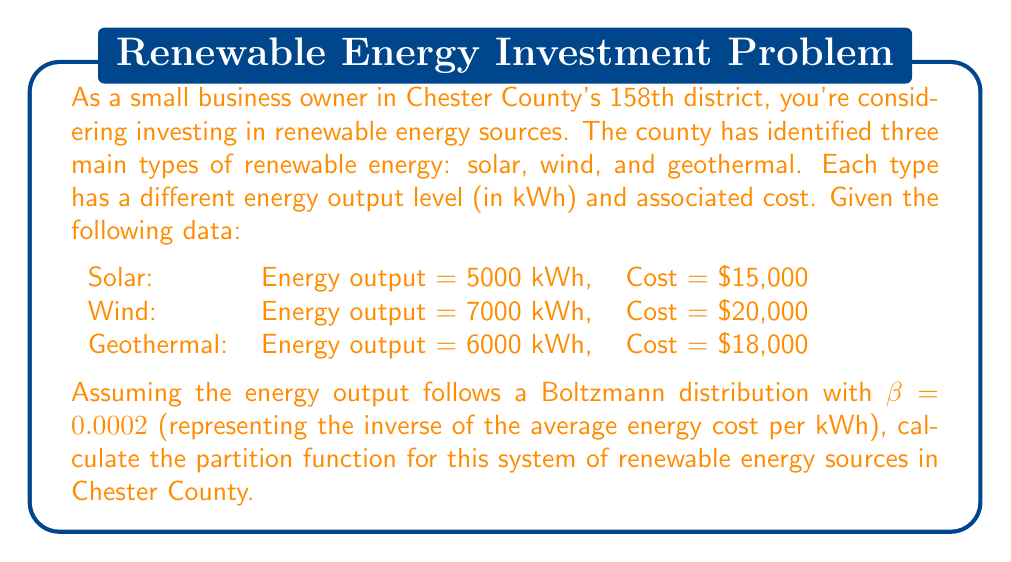Give your solution to this math problem. To solve this problem, we'll follow these steps:

1) Recall that the partition function Z for a system with discrete energy levels is given by:

   $$Z = \sum_i e^{-\beta E_i}$$

   where $E_i$ are the energy levels and $\beta$ is the inverse temperature parameter.

2) In our case, $\beta = 0.0002$ and we have three energy levels corresponding to the three types of renewable energy sources.

3) Let's calculate the exponent for each energy source:

   Solar: $e^{-0.0002 \cdot 5000} = e^{-1} \approx 0.3679$
   Wind: $e^{-0.0002 \cdot 7000} = e^{-1.4} \approx 0.2466$
   Geothermal: $e^{-0.0002 \cdot 6000} = e^{-1.2} \approx 0.3012$

4) Now, we sum these values to get the partition function:

   $$Z = e^{-0.0002 \cdot 5000} + e^{-0.0002 \cdot 7000} + e^{-0.0002 \cdot 6000}$$

5) Substituting the calculated values:

   $$Z \approx 0.3679 + 0.2466 + 0.3012 = 0.9157$$

Thus, the partition function for this system of renewable energy sources in Chester County is approximately 0.9157.
Answer: $Z \approx 0.9157$ 